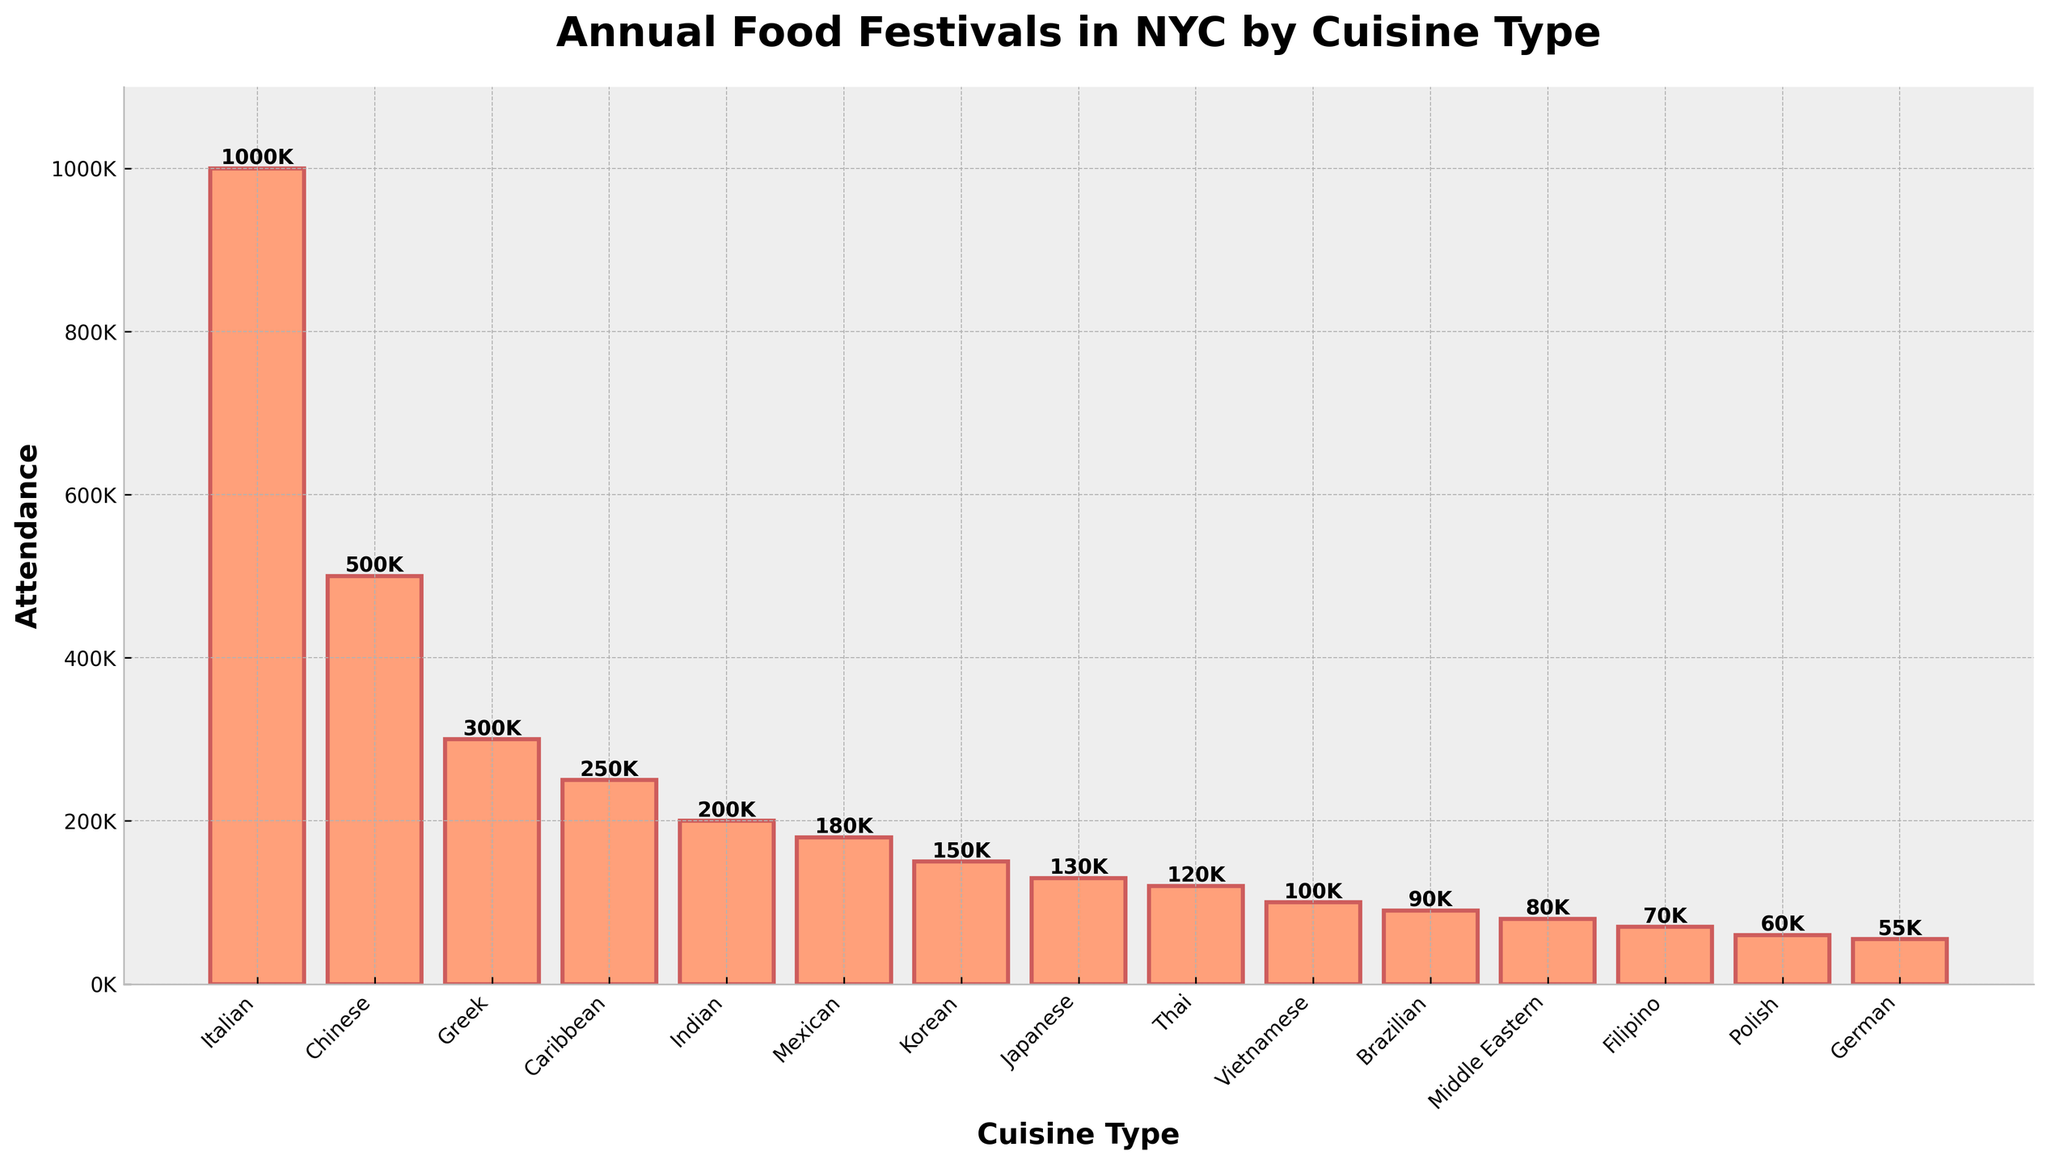Which cuisine type has the highest attendance? The highest bar represents the cuisine type with the highest attendance. In this plot, the Italian cuisine type has the highest attendance.
Answer: Italian How many attendees are there for the Greek and Caribbean festivals combined? From the plot, the Greek Food Festival has 300,000 attendees and the Caribbean Food Festival has 250,000 attendees. Adding these two numbers together gives 300,000 + 250,000 = 550,000.
Answer: 550,000 Which festival has the lowest attendance? The shortest bar represents the festival with the lowest attendance. In this plot, the German cuisine type (Oktoberfest) has the lowest attendance.
Answer: Oktoberfest How much more attendance does the Feast of San Gennaro have compared to the Lunar New Year Festival? The plot shows the Feast of San Gennaro has 1,000,000 attendees while the Lunar New Year Festival has 500,000. The difference is 1,000,000 - 500,000 = 500,000.
Answer: 500,000 What is the average attendance of all the festivals? Sum all attendance numbers (1000000 + 500000 + 300000 + 250000 + 200000 + 180000 + 150000 + 130000 + 120000 + 100000 + 90000 + 80000 + 70000 + 60000 + 55000) which equals 3165000. Divide this by the number of festivals (15). So, 3165000 / 15 = 211,000.
Answer: 211,000 Which cuisine types have attendance numbers greater than 200,000? From visual observation, the bars for Italian, Chinese, and Greek cuisine types have attendance numbers greater than 200,000.
Answer: Italian, Chinese, Greek By how much does the attendance for Brazilian Day Festival exceed the Arab American Street Festival? The attendance for the Brazilian Day Festival is 90,000, and for the Arab American Street Festival is 80,000. The difference is 90,000 - 80,000 = 10,000.
Answer: 10,000 Between the Diwali Food Festival and the Cinco de Mayo Food Fair, which has higher attendance, and by how much? The Diwali Food Festival has 200,000 attendees, while the Cinco de Mayo Food Fair has 180,000. The difference is 200,000 - 180,000 = 20,000.
Answer: Diwali Food Festival, 20,000 排列食物节名称从最高到最低出人意料? 按出人意料安排从高到低的食物节分别为Feast of San Gennaro (意大利), Lunar New Year Festival (中国), Greek Food Festival (希腊), Caribbean Food Festival (加勒比), Diwali Food Festival (印度), Cinco de Mayo Food Fair (墨西哥), Korean Food Festival (韩国), Japan Fes (日本), Thai Food and Culture Festival (泰国), Pho Festival (越南), Brazilian Day Festival (巴西), Arab American Street Festival (中东), Filipino Street Fair (菲律宾), Polish Festival (波兰), Oktoberfest (德国).
Answer: 在给定的食物节中从最高到最低排列 How much is the total attendance of the least popular five festivals? The least popular five festivals are German (55,000), Polish (60,000), Filipino (70,000), Middle Eastern (80,000), and Brazilian (90,000). The total is 55,000 + 60,000 + 70,000 + 80,000 + 90,000 = 355,000.
Answer: 355,000 